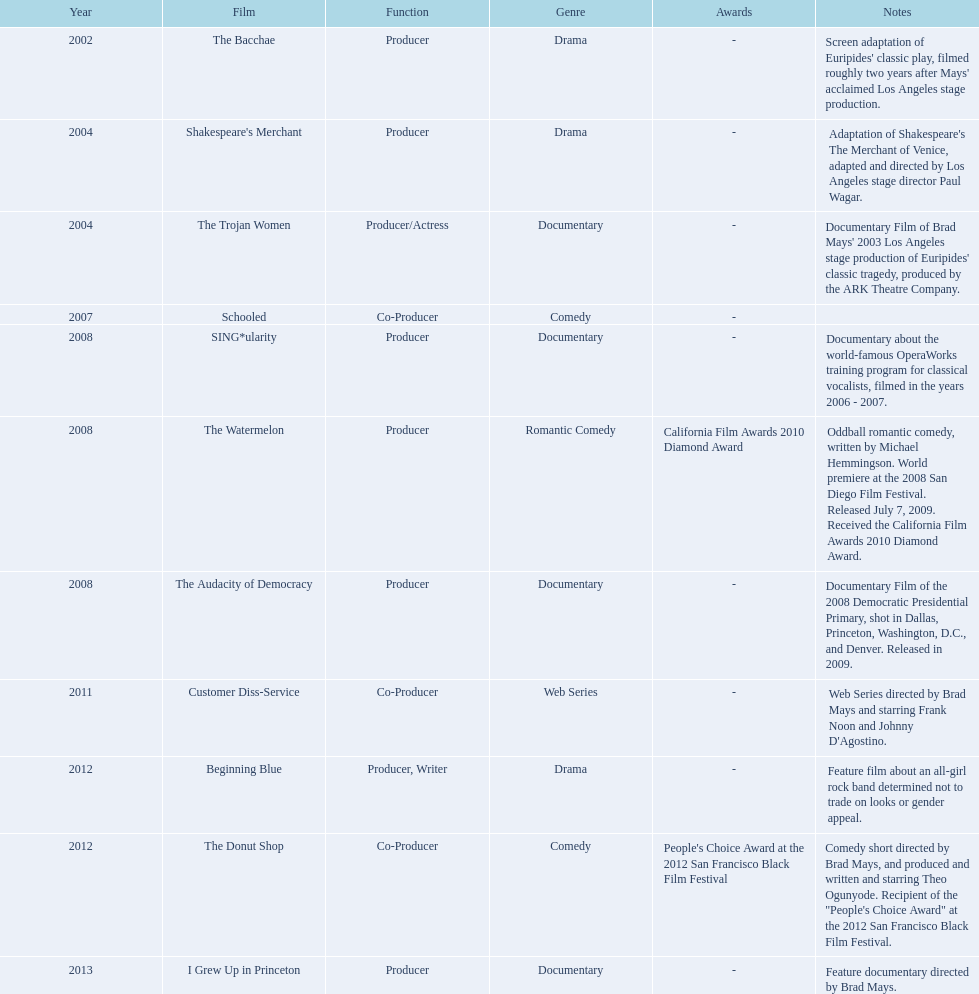In which year did ms. starfelt produce the most films? 2008. 